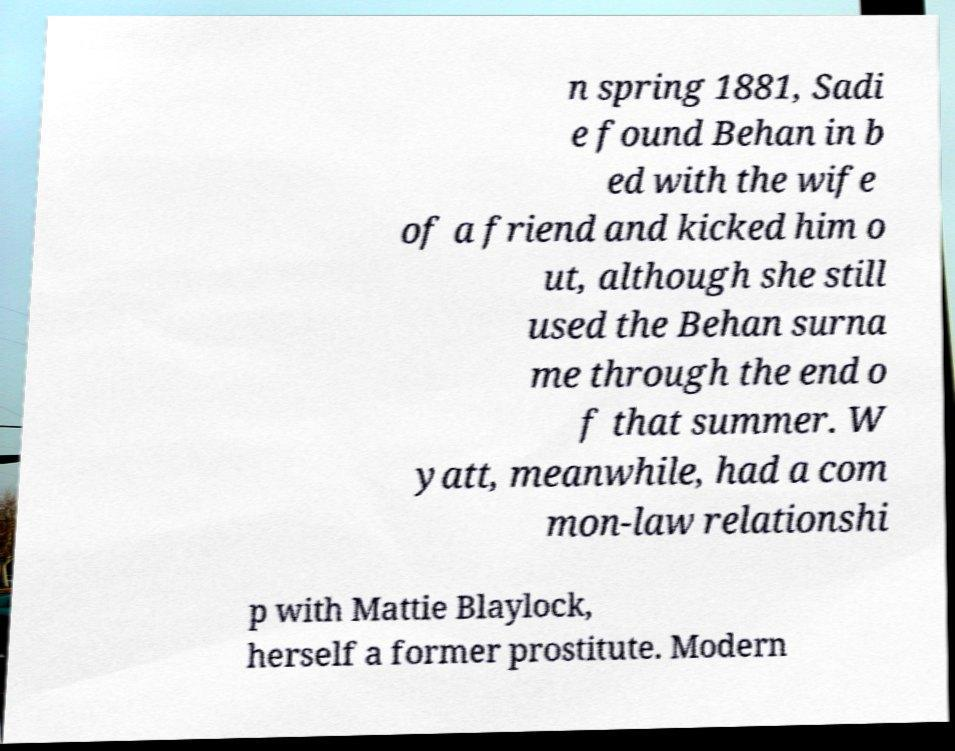Could you assist in decoding the text presented in this image and type it out clearly? n spring 1881, Sadi e found Behan in b ed with the wife of a friend and kicked him o ut, although she still used the Behan surna me through the end o f that summer. W yatt, meanwhile, had a com mon-law relationshi p with Mattie Blaylock, herself a former prostitute. Modern 